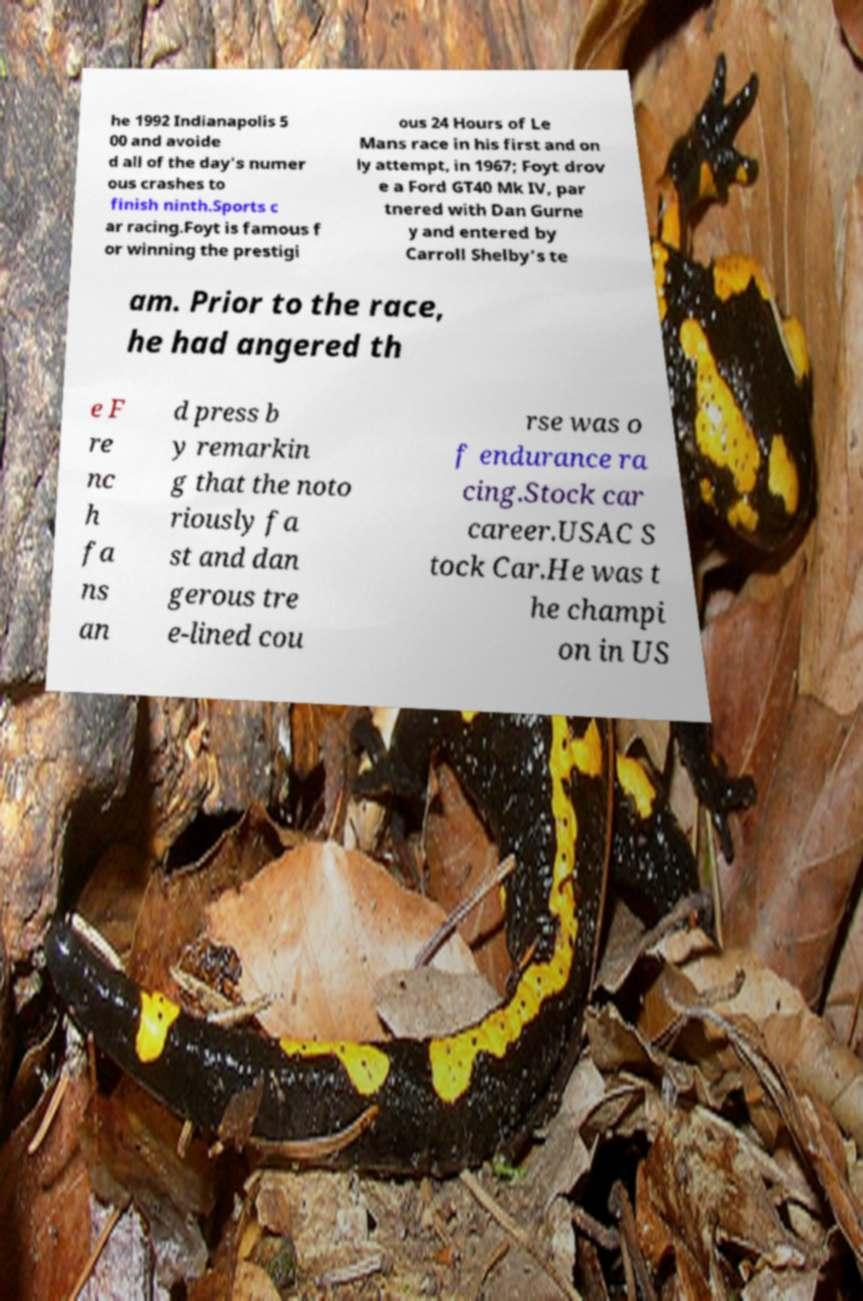Please identify and transcribe the text found in this image. he 1992 Indianapolis 5 00 and avoide d all of the day's numer ous crashes to finish ninth.Sports c ar racing.Foyt is famous f or winning the prestigi ous 24 Hours of Le Mans race in his first and on ly attempt, in 1967; Foyt drov e a Ford GT40 Mk IV, par tnered with Dan Gurne y and entered by Carroll Shelby's te am. Prior to the race, he had angered th e F re nc h fa ns an d press b y remarkin g that the noto riously fa st and dan gerous tre e-lined cou rse was o f endurance ra cing.Stock car career.USAC S tock Car.He was t he champi on in US 